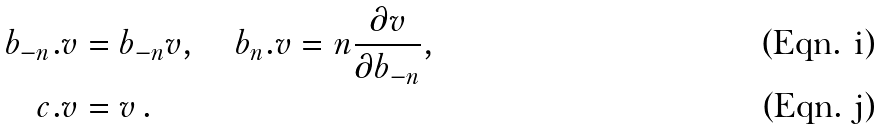<formula> <loc_0><loc_0><loc_500><loc_500>b _ { - n } . v & = b _ { - n } v , \quad b _ { n } . v = n \frac { \partial v } { \partial b _ { - n } } , \\ c . v & = v \, .</formula> 